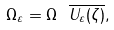Convert formula to latex. <formula><loc_0><loc_0><loc_500><loc_500>\Omega _ { \varepsilon } = \Omega \ \overline { U _ { \varepsilon } ( \zeta ) } ,</formula> 